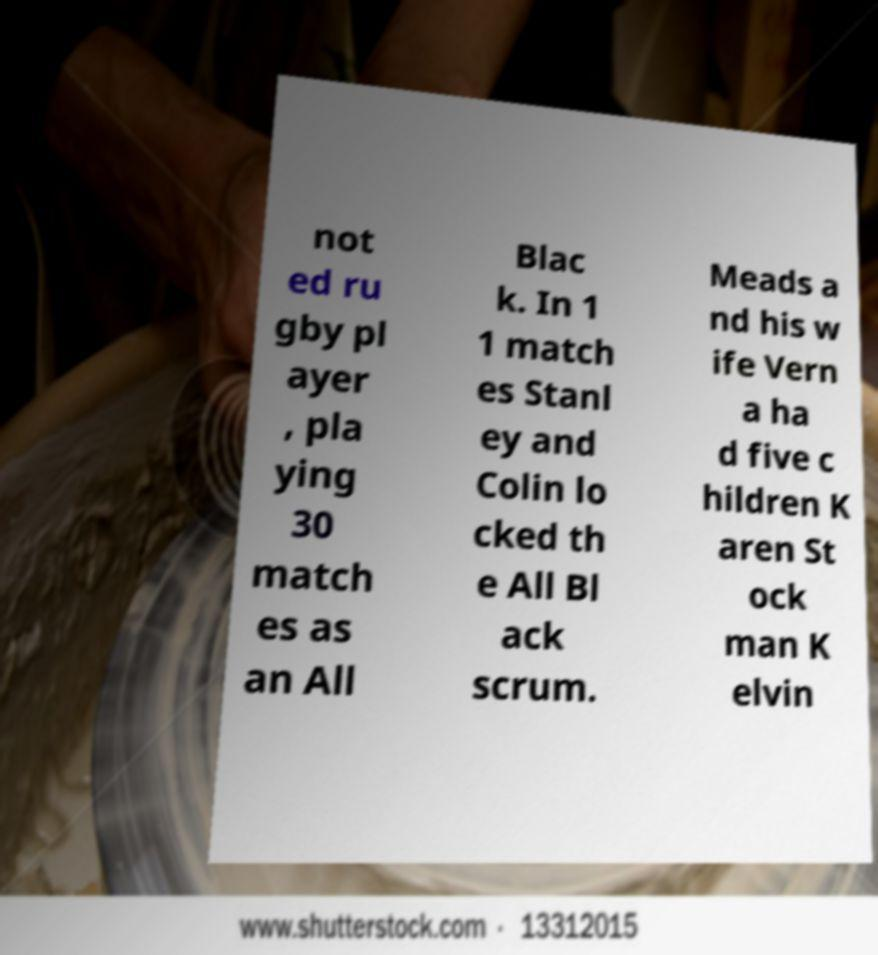I need the written content from this picture converted into text. Can you do that? not ed ru gby pl ayer , pla ying 30 match es as an All Blac k. In 1 1 match es Stanl ey and Colin lo cked th e All Bl ack scrum. Meads a nd his w ife Vern a ha d five c hildren K aren St ock man K elvin 